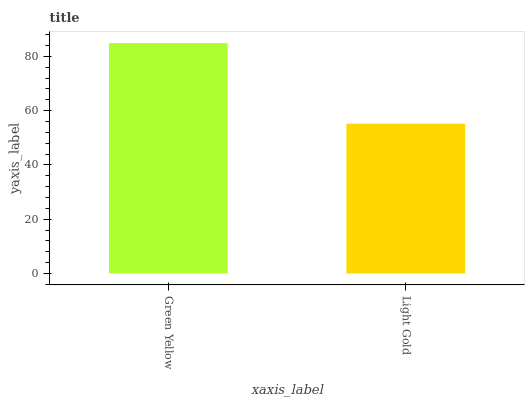Is Light Gold the minimum?
Answer yes or no. Yes. Is Green Yellow the maximum?
Answer yes or no. Yes. Is Light Gold the maximum?
Answer yes or no. No. Is Green Yellow greater than Light Gold?
Answer yes or no. Yes. Is Light Gold less than Green Yellow?
Answer yes or no. Yes. Is Light Gold greater than Green Yellow?
Answer yes or no. No. Is Green Yellow less than Light Gold?
Answer yes or no. No. Is Green Yellow the high median?
Answer yes or no. Yes. Is Light Gold the low median?
Answer yes or no. Yes. Is Light Gold the high median?
Answer yes or no. No. Is Green Yellow the low median?
Answer yes or no. No. 